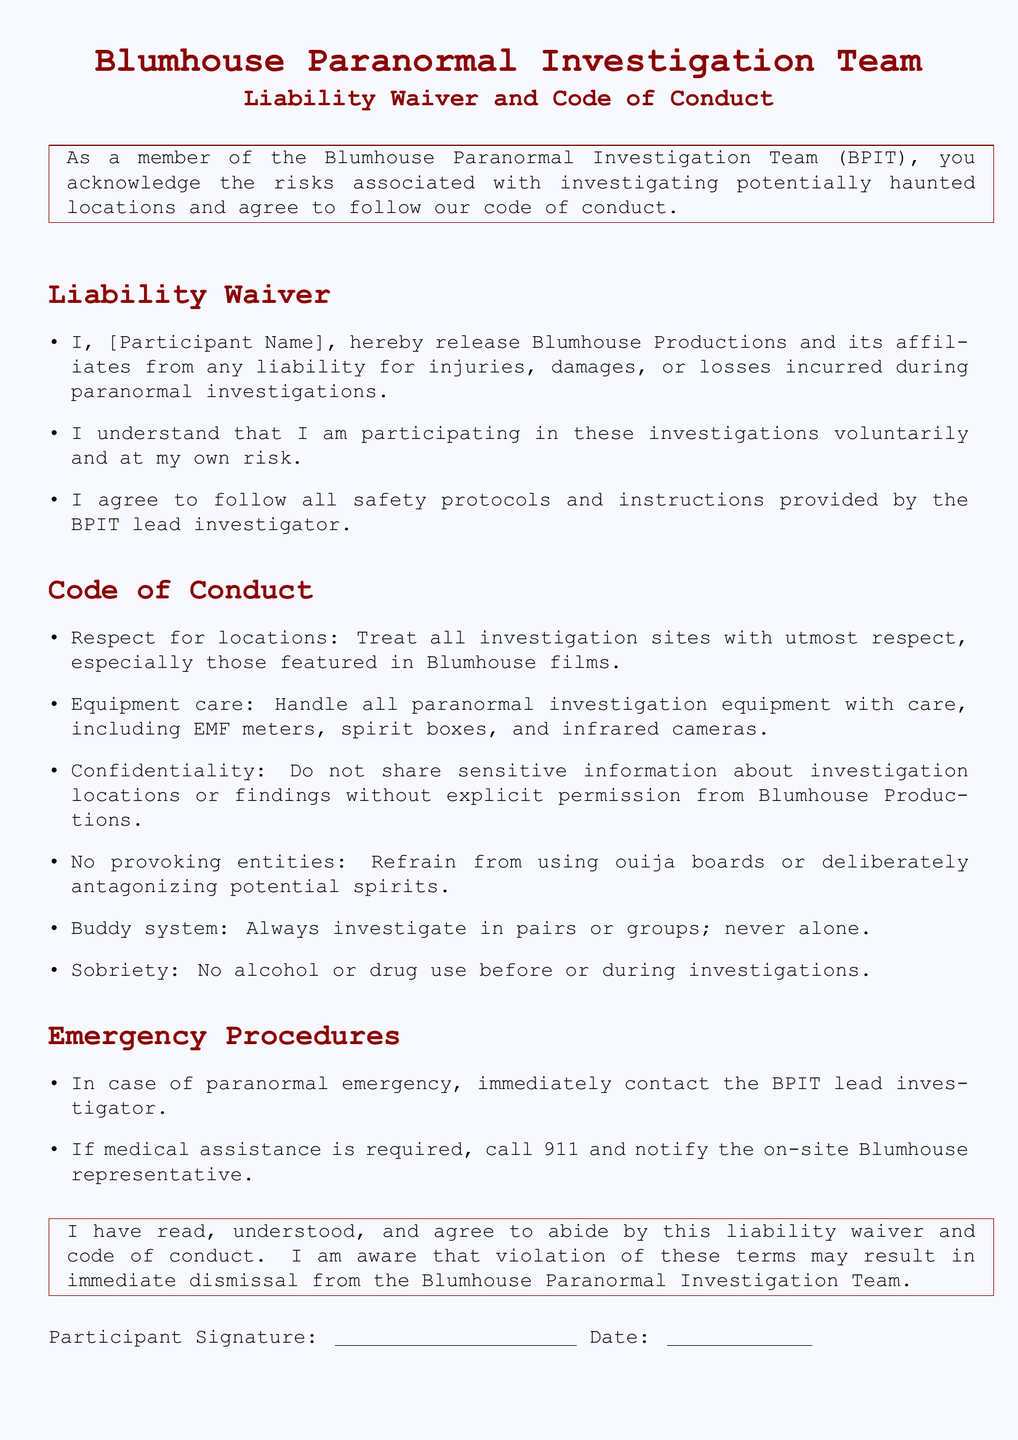What is the title of the document? The title is stated in the document's header and is centered at the top.
Answer: Blumhouse Paranormal Investigation Team Liability Waiver and Code of Conduct What must a participant do to release Blumhouse Productions from liability? This information is found in the liability waiver section, which contains specific actions a participant must agree to.
Answer: Release What is required of participants regarding equipment? This question refers to the expectations set forth in the Code of Conduct section regarding the handling of equipment.
Answer: Handle with care What should participants refrain from using during investigations? The Code of Conduct section outlines specific actions to avoid, including certain tools or methods.
Answer: Ouija boards What should a participant do in case of a paranormal emergency? This response can be found in the Emergency Procedures section of the document, specifying actions in emergencies.
Answer: Contact the lead investigator How must participants investigate? This is specified in the Code of Conduct section, which outlines how team members should conduct investigations.
Answer: In pairs or groups What is the date format for signing the document? The signature section of the document indicates how participants are required to date their signature.
Answer: Not specified What happens if a participant violates the code of conduct? The consequence of violating the document's terms is mentioned in the spookybox at the end.
Answer: Dismissal 